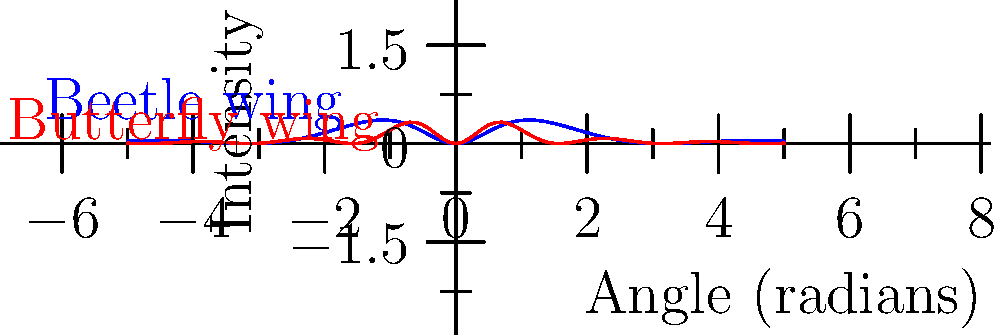The graph shows the diffraction patterns created by light passing through the wing structures of two different Galápagos insects. How does the pattern for the beetle wing (blue) differ from the butterfly wing (red), and what does this suggest about their wing structures? To analyze the diffraction patterns:

1. Peak intensity: The beetle wing (blue) shows a higher maximum intensity compared to the butterfly wing (red).

2. Central peak width: The central peak of the beetle pattern is narrower than that of the butterfly.

3. Secondary maxima: The beetle pattern has more pronounced secondary maxima compared to the butterfly pattern.

4. Pattern periodicity: The butterfly pattern shows a higher frequency of oscillation, indicating closer spacing of diffracting elements.

These differences suggest:

a) The beetle wing likely has larger, more uniform structures causing diffraction, resulting in a more intense and focused central peak.

b) The butterfly wing probably has smaller, more closely spaced structures, leading to a broader central peak and more rapid decay of intensity at larger angles.

c) The more pronounced secondary maxima in the beetle pattern suggest a more regular, crystalline-like arrangement of diffracting elements.

This analysis demonstrates how Darwin's observational techniques can be extended using modern physics to infer structural differences in organisms, potentially relating to their evolutionary adaptations.
Answer: Beetle wing: larger, more uniform structures; Butterfly wing: smaller, closely spaced structures 